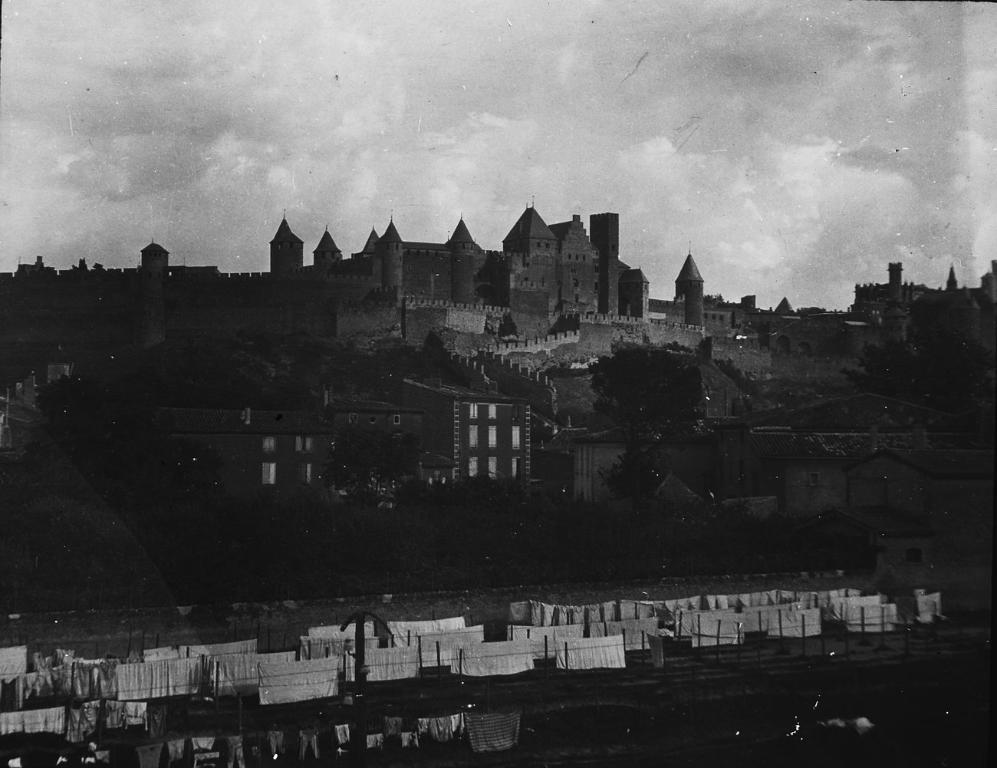What type of structure is the main subject of the image? There is a fort in the image. What other structures can be seen in the image? There are buildings in the image. What type of natural elements are present in the image? There are trees in the image. What is the color scheme of the image? The image is black and white. What is the condition of the sky in the image? The sky is clear in the image. What type of basketball court can be seen in the image? There is no basketball court present in the image. Can you tell me how many drums are visible in the image? There are no drums present in the image. 